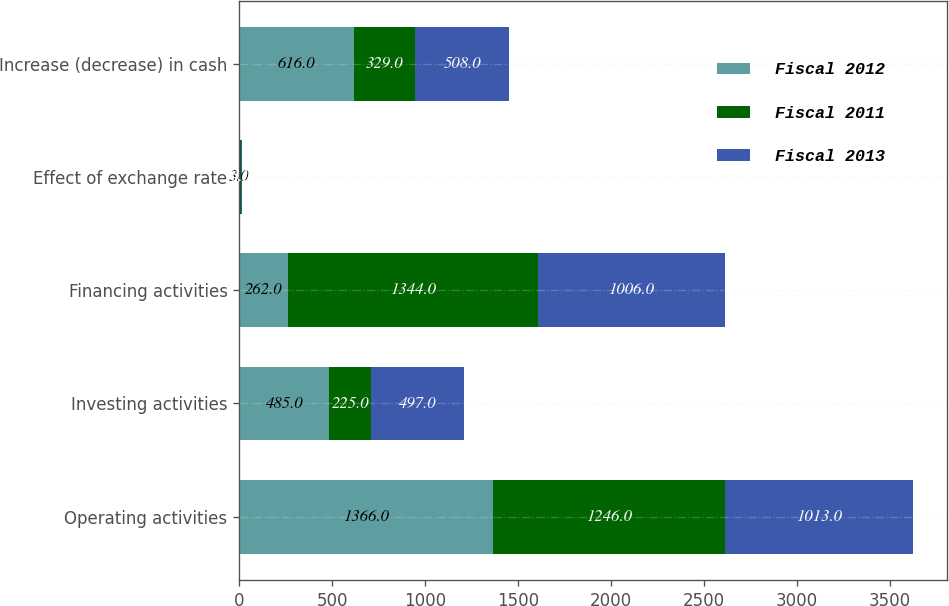<chart> <loc_0><loc_0><loc_500><loc_500><stacked_bar_chart><ecel><fcel>Operating activities<fcel>Investing activities<fcel>Financing activities<fcel>Effect of exchange rate<fcel>Increase (decrease) in cash<nl><fcel>Fiscal 2012<fcel>1366<fcel>485<fcel>262<fcel>3<fcel>616<nl><fcel>Fiscal 2011<fcel>1246<fcel>225<fcel>1344<fcel>6<fcel>329<nl><fcel>Fiscal 2013<fcel>1013<fcel>497<fcel>1006<fcel>4<fcel>508<nl></chart> 